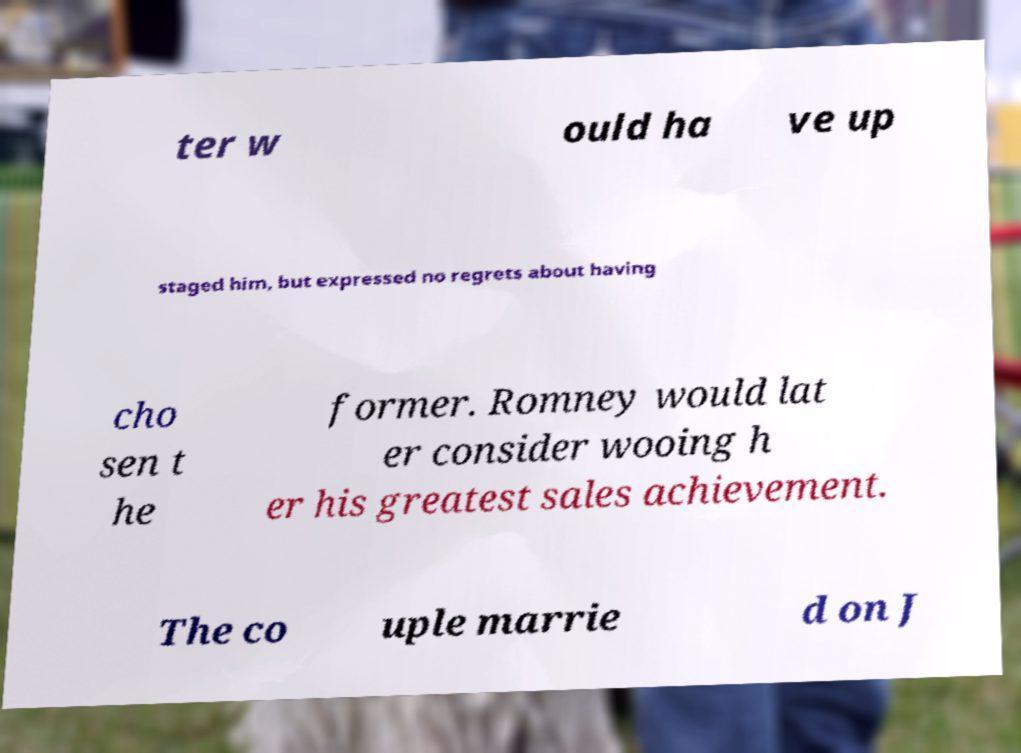Could you extract and type out the text from this image? ter w ould ha ve up staged him, but expressed no regrets about having cho sen t he former. Romney would lat er consider wooing h er his greatest sales achievement. The co uple marrie d on J 